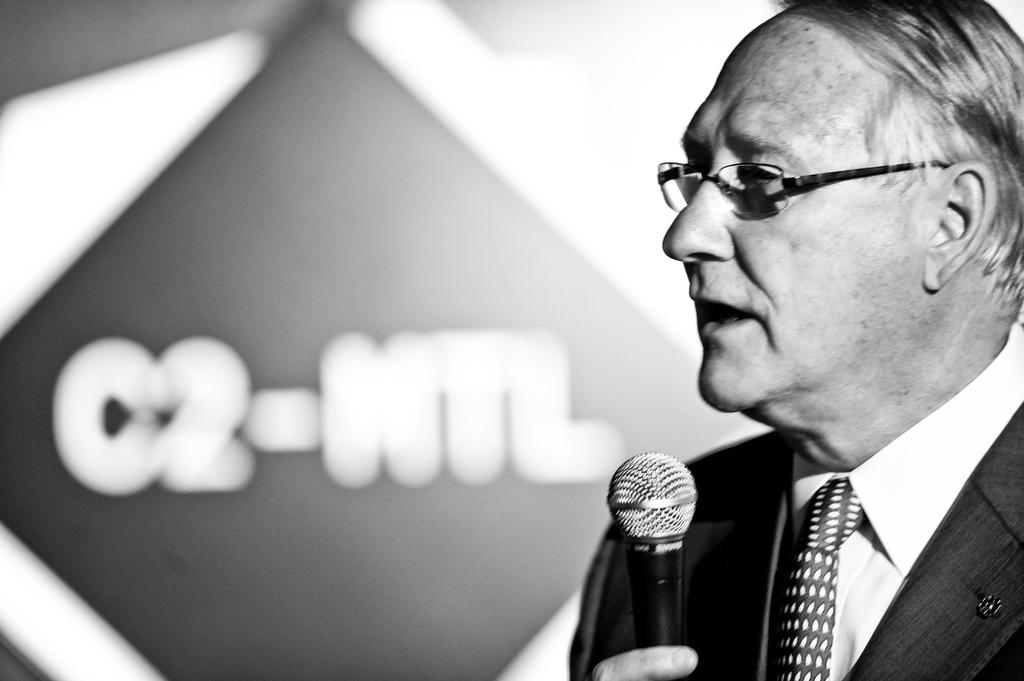What is the color scheme of the image? The image is black and white. What is the man in the image doing? The man is standing and talking in the image. What is the man holding in the image? The man is holding a microphone in the image. What can be seen in the background of the image? There is a banner in the background of the image. What type of clothing is the man wearing? The man is wearing a suit, a shirt, a tie, and spectacles in the image. Can you see a river flowing in the background of the image? No, there is no river visible in the image. What type of jelly is the man eating in the image? There is no jelly present in the image; the man is holding a microphone and talking. 